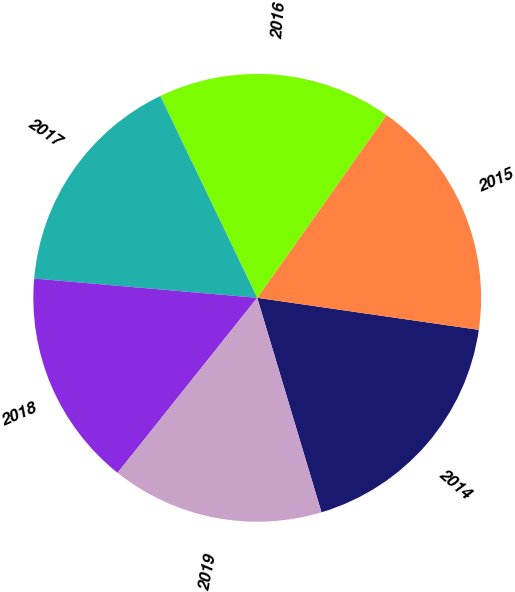<chart> <loc_0><loc_0><loc_500><loc_500><pie_chart><fcel>2014<fcel>2015<fcel>2016<fcel>2017<fcel>2018<fcel>2019<nl><fcel>18.08%<fcel>17.48%<fcel>16.93%<fcel>16.5%<fcel>15.65%<fcel>15.35%<nl></chart> 